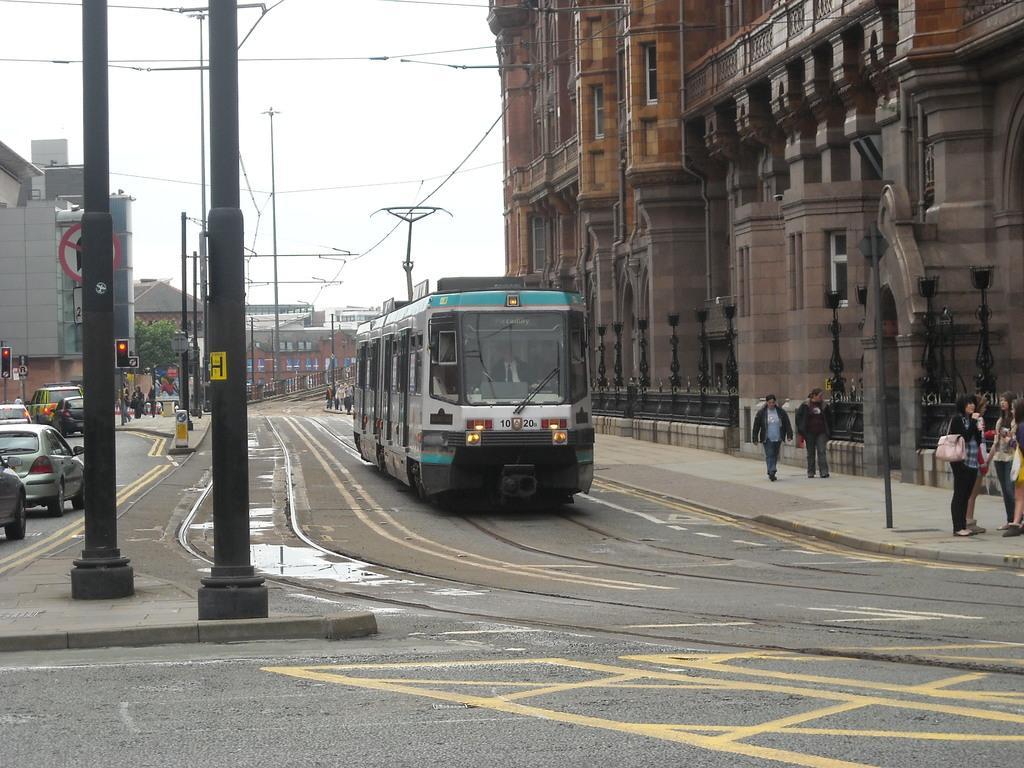Could you give a brief overview of what you see in this image? This picture is clicked outside the city. At the bottom, we see the road. In the middle, we see the train moving on the tracks. On the right side, we see the people are standing. Beside them, we see a pole. Beside that, we see two people are standing on the footpath. On the right side, we see the poles and a building. On the left side, we see the poles, traffic signals and the cars moving on the road. There are trees, buildings and the poles in the background. We see the people are standing on the road. At the top, we see the sky and the wires. 